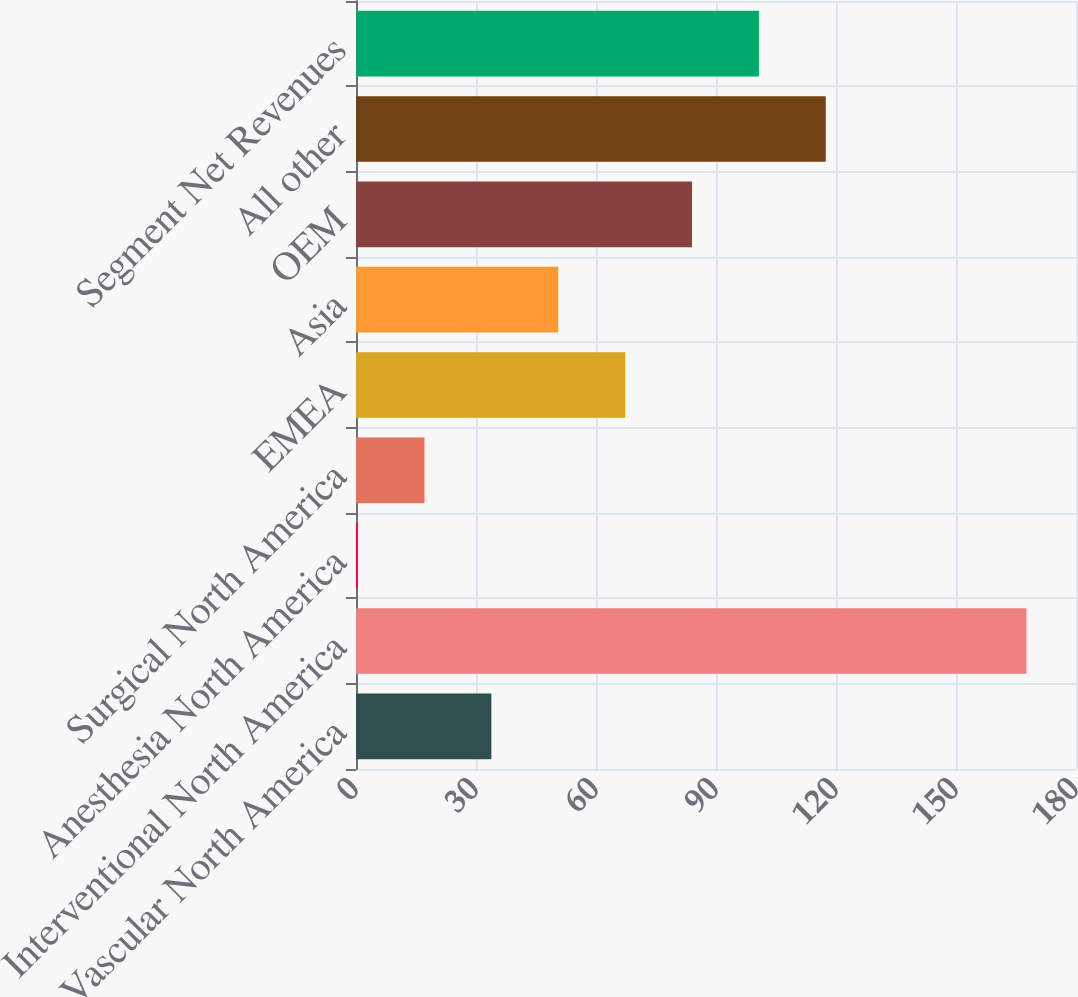Convert chart to OTSL. <chart><loc_0><loc_0><loc_500><loc_500><bar_chart><fcel>Vascular North America<fcel>Interventional North America<fcel>Anesthesia North America<fcel>Surgical North America<fcel>EMEA<fcel>Asia<fcel>OEM<fcel>All other<fcel>Segment Net Revenues<nl><fcel>33.84<fcel>167.6<fcel>0.4<fcel>17.12<fcel>67.28<fcel>50.56<fcel>84<fcel>117.44<fcel>100.72<nl></chart> 